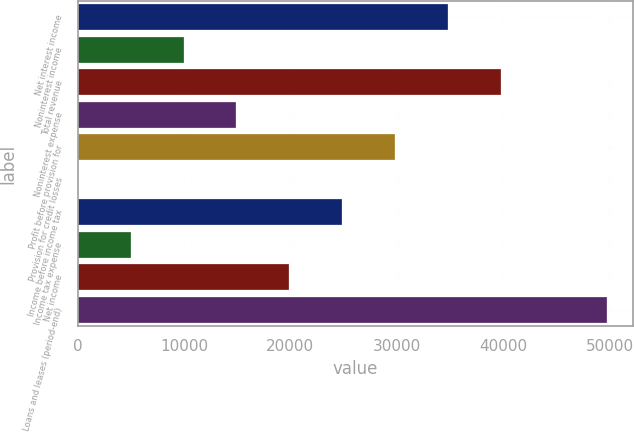<chart> <loc_0><loc_0><loc_500><loc_500><bar_chart><fcel>Net interest income<fcel>Noninterest income<fcel>Total revenue<fcel>Noninterest expense<fcel>Profit before provision for<fcel>Provision for credit losses<fcel>Income before income tax<fcel>Income tax expense<fcel>Net income<fcel>Loans and leases (period-end)<nl><fcel>34828.6<fcel>9964.6<fcel>39801.4<fcel>14937.4<fcel>29855.8<fcel>19<fcel>24883<fcel>4991.8<fcel>19910.2<fcel>49747<nl></chart> 